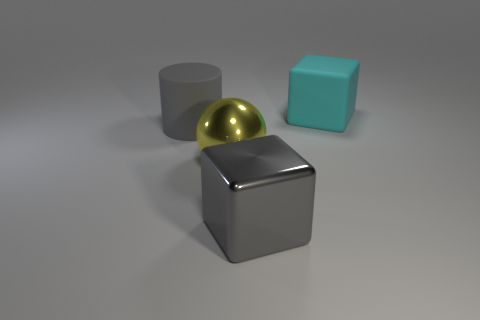Add 4 cyan matte objects. How many objects exist? 8 Subtract all cylinders. How many objects are left? 3 Subtract 0 cyan cylinders. How many objects are left? 4 Subtract all gray blocks. Subtract all gray matte cylinders. How many objects are left? 2 Add 2 gray cubes. How many gray cubes are left? 3 Add 3 big gray rubber cylinders. How many big gray rubber cylinders exist? 4 